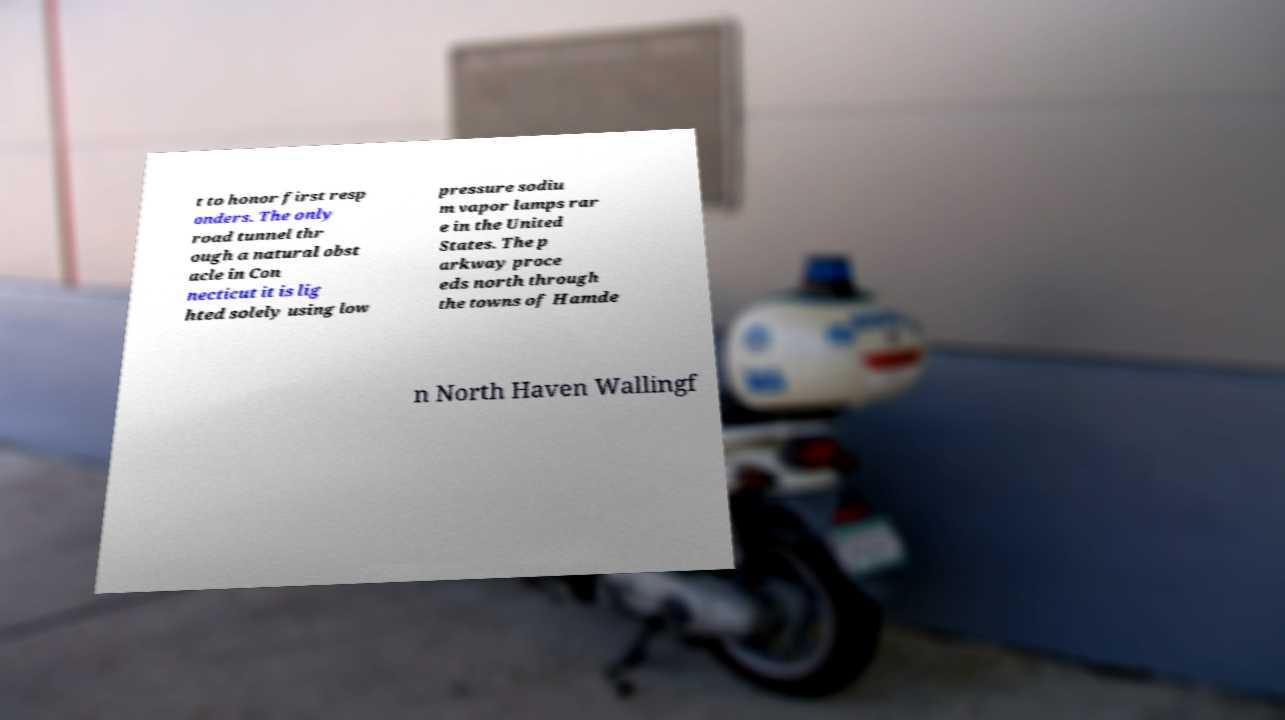Can you read and provide the text displayed in the image?This photo seems to have some interesting text. Can you extract and type it out for me? t to honor first resp onders. The only road tunnel thr ough a natural obst acle in Con necticut it is lig hted solely using low pressure sodiu m vapor lamps rar e in the United States. The p arkway proce eds north through the towns of Hamde n North Haven Wallingf 